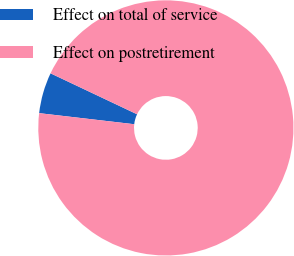Convert chart. <chart><loc_0><loc_0><loc_500><loc_500><pie_chart><fcel>Effect on total of service<fcel>Effect on postretirement<nl><fcel>5.19%<fcel>94.81%<nl></chart> 